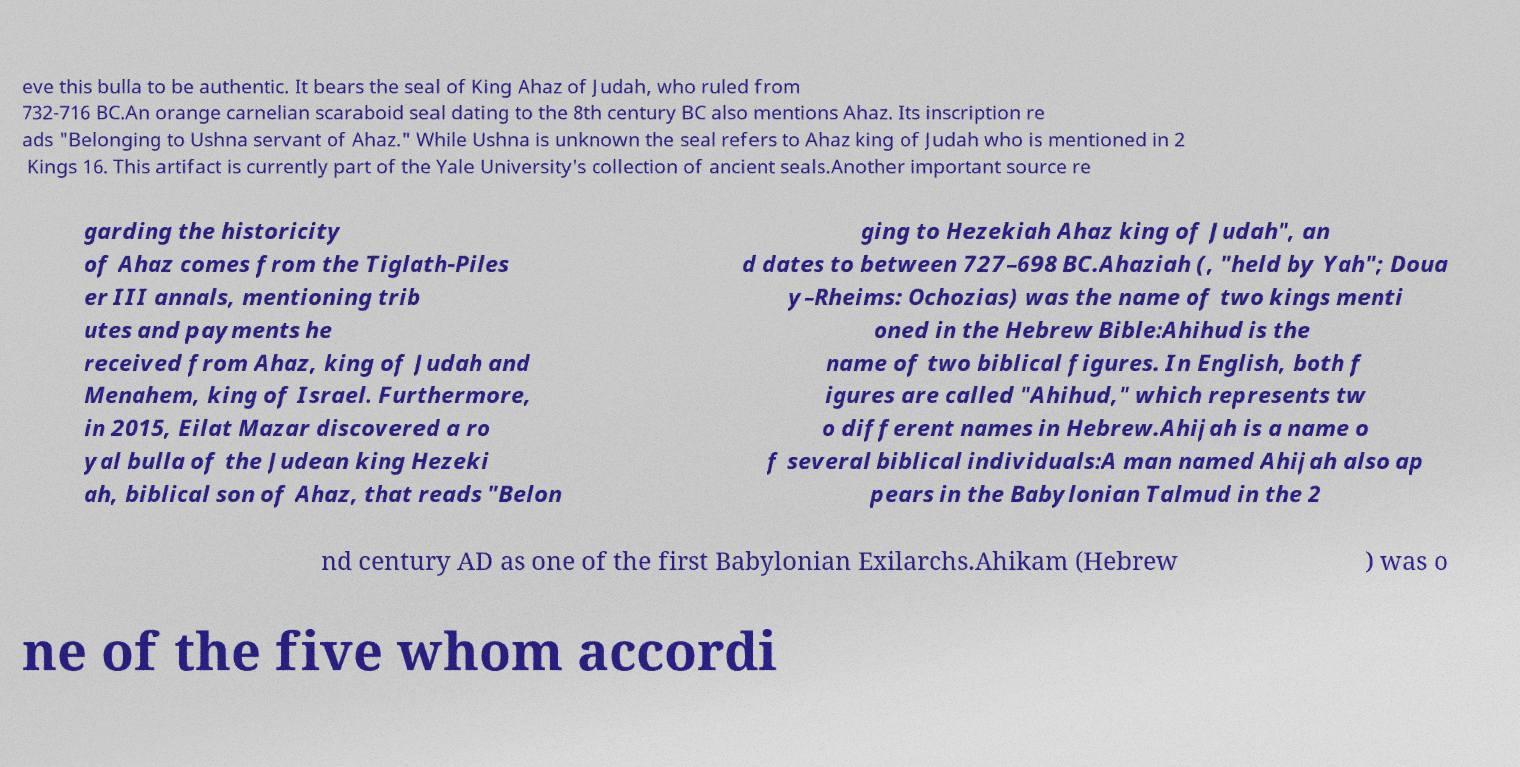Can you read and provide the text displayed in the image?This photo seems to have some interesting text. Can you extract and type it out for me? eve this bulla to be authentic. It bears the seal of King Ahaz of Judah, who ruled from 732-716 BC.An orange carnelian scaraboid seal dating to the 8th century BC also mentions Ahaz. Its inscription re ads "Belonging to Ushna servant of Ahaz." While Ushna is unknown the seal refers to Ahaz king of Judah who is mentioned in 2 Kings 16. This artifact is currently part of the Yale University's collection of ancient seals.Another important source re garding the historicity of Ahaz comes from the Tiglath-Piles er III annals, mentioning trib utes and payments he received from Ahaz, king of Judah and Menahem, king of Israel. Furthermore, in 2015, Eilat Mazar discovered a ro yal bulla of the Judean king Hezeki ah, biblical son of Ahaz, that reads "Belon ging to Hezekiah Ahaz king of Judah", an d dates to between 727–698 BC.Ahaziah (, "held by Yah"; Doua y–Rheims: Ochozias) was the name of two kings menti oned in the Hebrew Bible:Ahihud is the name of two biblical figures. In English, both f igures are called "Ahihud," which represents tw o different names in Hebrew.Ahijah is a name o f several biblical individuals:A man named Ahijah also ap pears in the Babylonian Talmud in the 2 nd century AD as one of the first Babylonian Exilarchs.Ahikam (Hebrew ) was o ne of the five whom accordi 